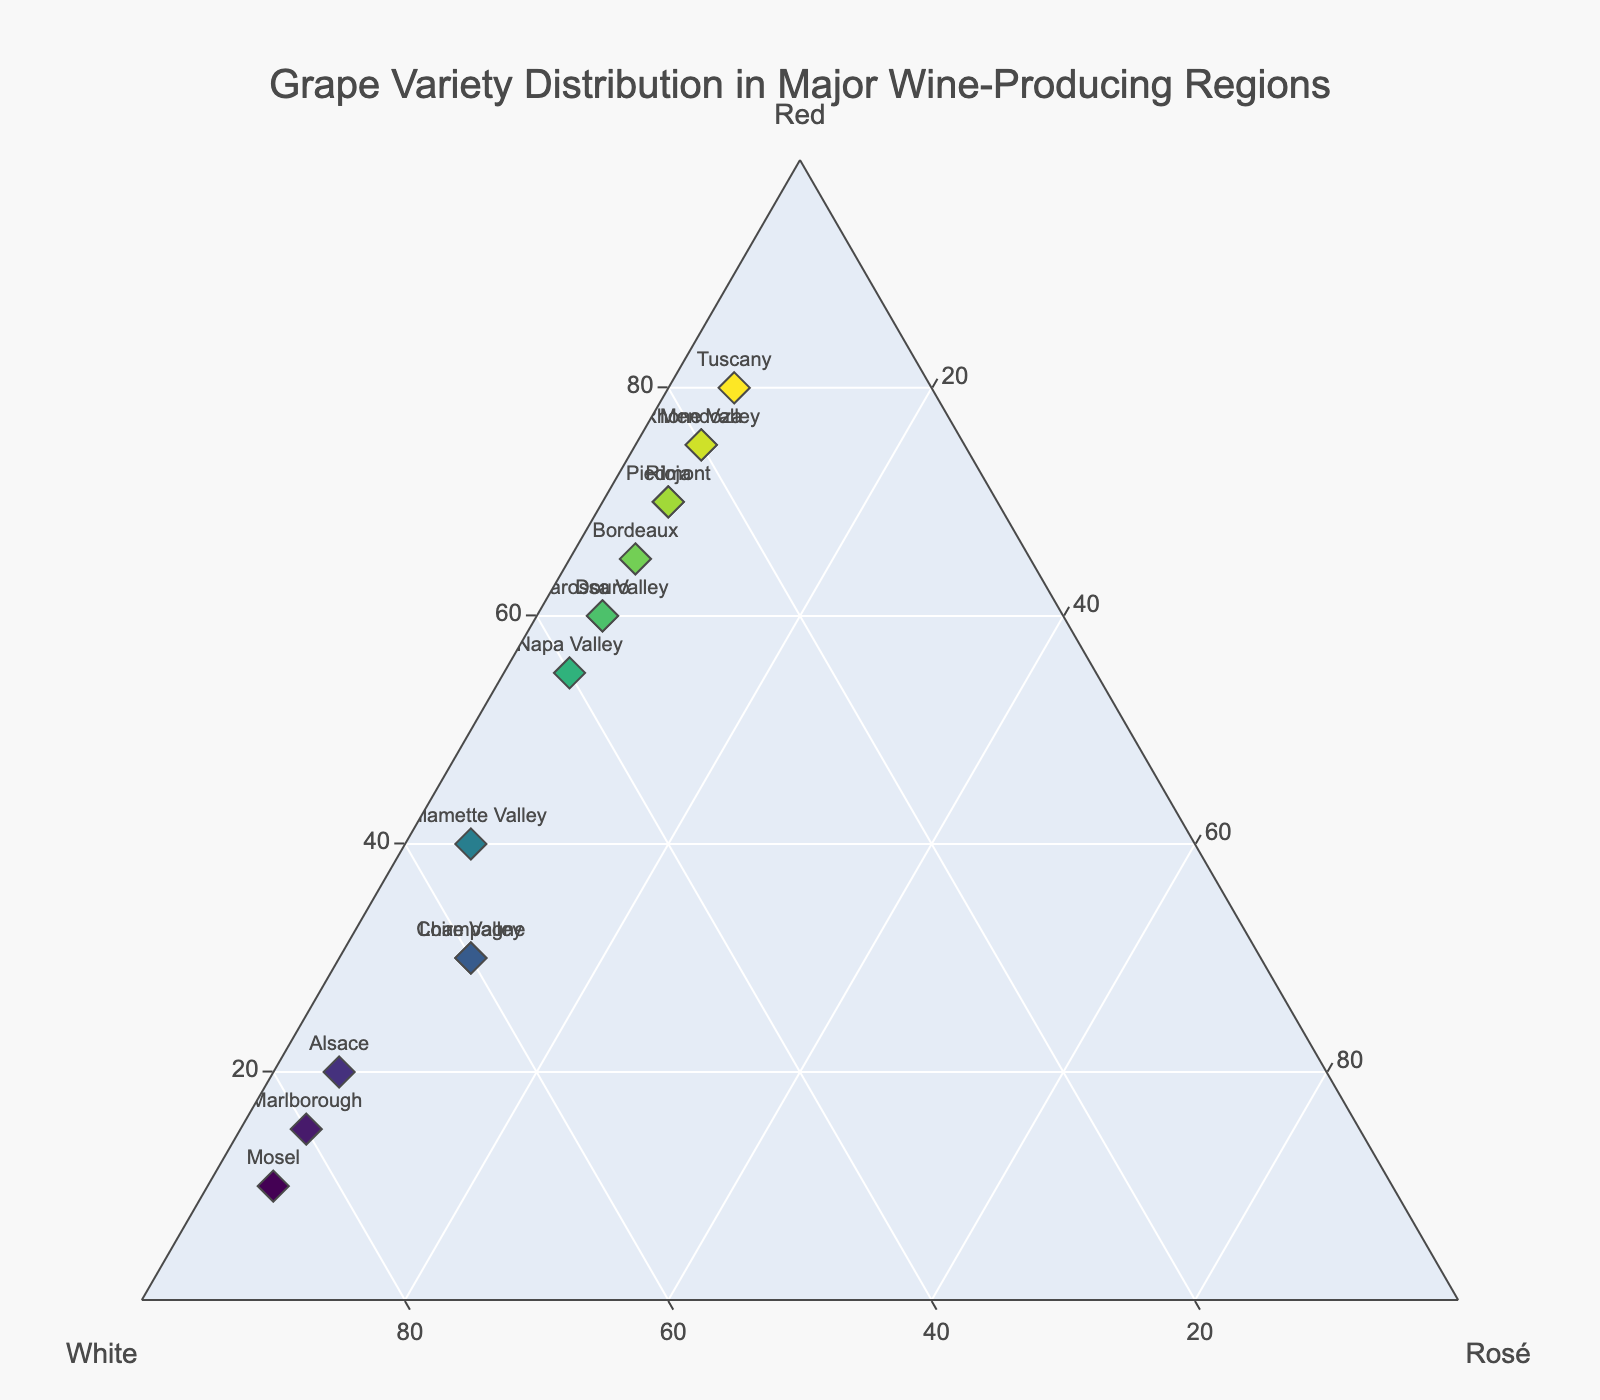What's the title of the figure? The title of the figure is displayed at the top center of the plot in bold. It summarizes the data being represented.
Answer: Grape Variety Distribution in Major Wine-Producing Regions How many regions have more than 70% Red variety? Count the data points on the Ternary Plot that have the 'Red' axis value greater than 70%.
Answer: 5 Which region has the highest percentage of White variety? Find the data point positioned highest on the 'White' axis.
Answer: Mosel Which regions have an equal percentage of Rosé variety? Identify the data points that have the same value for the 'Rosé' axis. The consistent value is 5% for multiple regions.
Answer: All except Champagne and Loire Valley What is the average percentage of White variety across all regions? Sum the percentages of White variety from all regions and divide by the total number of regions. (30 + 15 + 40 + 25 + 60 + 85 + 20 + 35 + 60 + 25 + 20 + 80 + 35 + 55 + 75) / 15
Answer: 41.67% Which region has a higher percentage of Rosé variety, Champagne or Douro? Compare the 'Rosé' values of Champagne and Douro.
Answer: Champagne What's the combined percentage of Red and White varieties in Burgundy? Find the percentages for Red and White in Burgundy, then sum them up. Note: Burgundy is not found in the provided dataset, so the expected approach is recognizing it's not listed.
Answer: Region not listed What is the most diverse region in terms of grape variety distribution? Look for the data point with the most even distribution among Red, White, and Rosé, where percentages are close to each other.
Answer: Willamette Valley How does the grape variety distribution of Bordeaux compare to Mendoza? Compare the 'Red', 'White', and 'Rosé' percentages for both regions.
Answer: Bordeaux (Red: 65, White: 30, Rosé: 5) has less Red and White, and the same Rosé compared to Mendoza (Red: 75, White: 20, Rosé: 5) What is the difference in the percentage of Red variety between the region with the highest Red and the one with the lowest Red? Identify the regions with the highest (Tuscany) and lowest (Mosel) Red variety percentages and subtract the latter from the former.
Answer: 80 - 10 = 70 